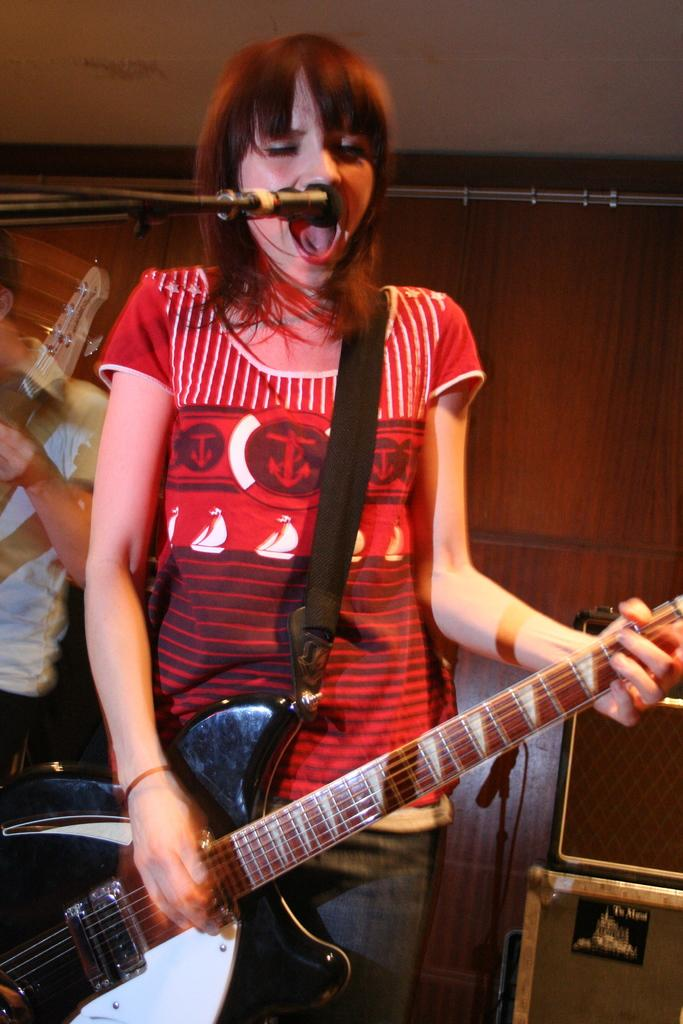Who is the main subject in the image? There is a woman in the image. What is the woman doing in the image? The woman is playing a guitar. What object is present in the image that is typically used for amplifying sound? There is a microphone in the image. How many bikes are parked in the middle of the image? There are no bikes present in the image. What are the woman's hobbies based on the image? The image only shows the woman playing a guitar, so we cannot determine her other hobbies from the image. 